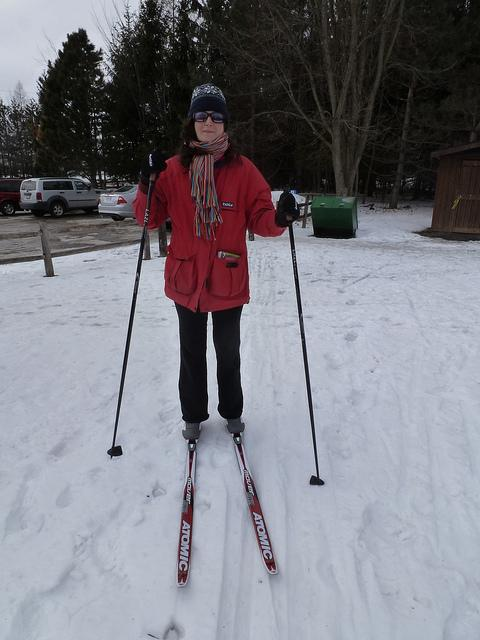Why is the woman wearing the covering around her neck? cold 